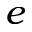Convert formula to latex. <formula><loc_0><loc_0><loc_500><loc_500>e</formula> 